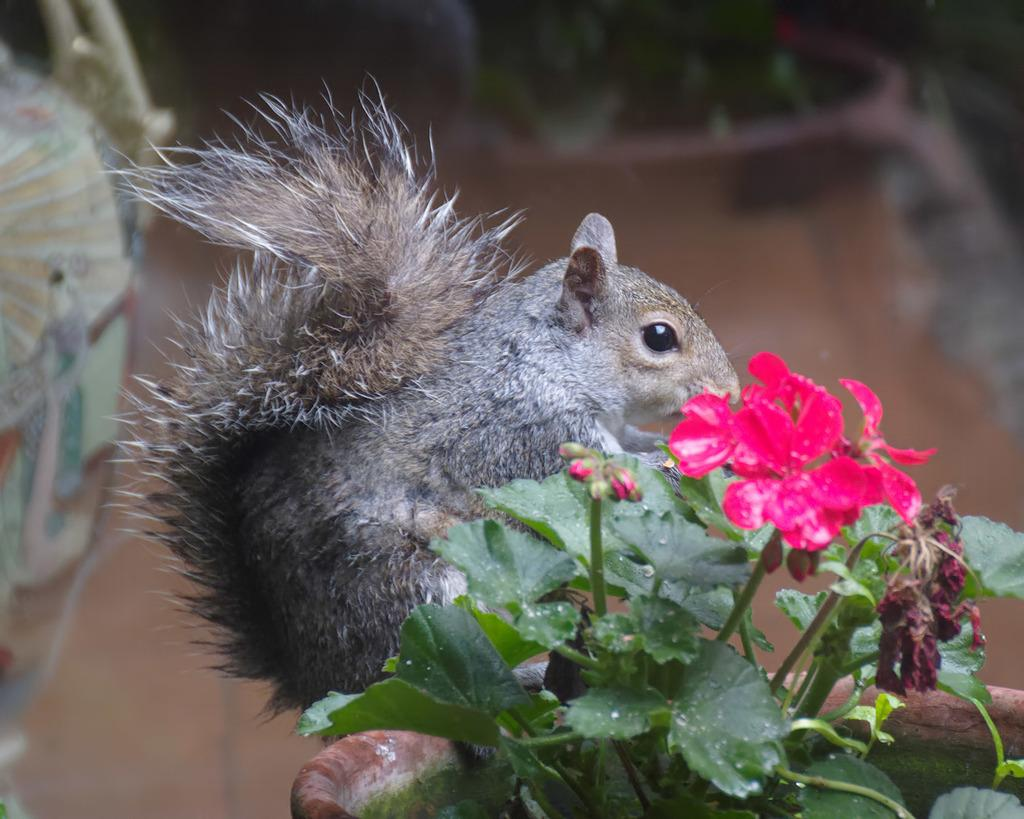What animal is present in the image? There is a squirrel in the image. What is the squirrel standing on? The squirrel is standing on a pot. What can be seen growing in the pot? There is a red flower on a plant in the pot. How would you describe the background of the image? The background of the image appears blurry. Can you tell me how many bears are shaking hands in the image? There are no bears or handshakes present in the image. 